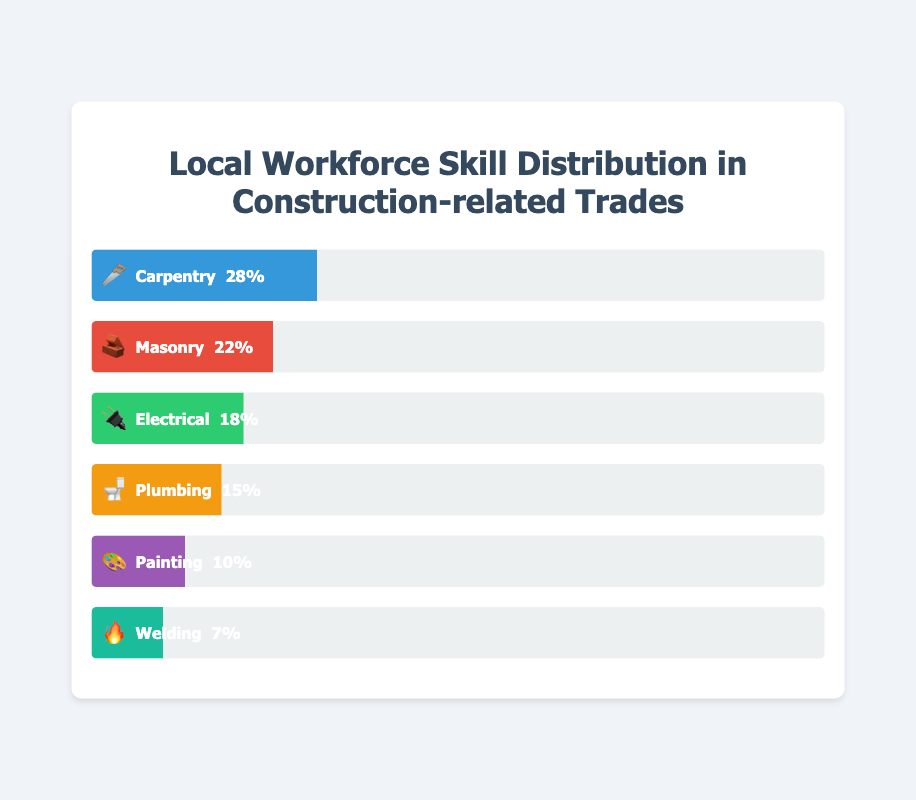What trade has the largest percentage of local workforce skills? The figure shows a bar representing each trade. The trade with the largest visible bar is "Carpentry 🪚." Its percentage is also noted on the bar.
Answer: Carpentry 🪚 What is the smallest percentage skill in construction-related trades? The figure lists percentages for each trade. The smallest number among them is "7%," attributed to "Welding 🔥."
Answer: Welding 🔥 What's the combined percentage of Electrical 🔌 and Plumbing 🚽 skills? Sum the percentages of Electrical (18%) and Plumbing (15%). The combined percentage is 18 + 15 = 33%.
Answer: 33% Which trade has a higher percentage, Painting 🎨 or Welding 🔥? Compare the percentages of Painting (10%) and Welding (7%). Painting's percentage is higher.
Answer: Painting 🎨 How much larger is the Carpentry 🪚 percentage compared to the Masonry 🧱 percentage? Subtract the percentage of Masonry (22%) from Carpentry (28%). The result is 28 - 22 = 6%.
Answer: 6% What's the total percentage of the local workforce skills represented in the figure? Add all the percentages: 28% (Carpentry) + 22% (Masonry) + 18% (Electrical) + 15% (Plumbing) + 10% (Painting) + 7% (Welding). The total is 28 + 22 + 18 + 15 + 10 + 7 = 100%.
Answer: 100% Which trade has the third highest percentage of local workforce skills? List the trades by percentage in descending order: 28% (Carpentry), 22% (Masonry), 18% (Electrical), 15% (Plumbing), 10% (Painting), and 7% (Welding). The third highest is Electrical at 18%.
Answer: Electrical 🔌 What is the difference in percentage points between the trade with the highest skill and the trade with the lowest skill? Subtract the percentage of the lowest skill (Welding, 7%) from the highest skill (Carpentry, 28%). The difference is 28 - 7 = 21%.
Answer: 21% If the skill distribution reflects the project needs, which two trades should receive more workforce training based on their current lower percentages? The two trades with the smallest percentages are Welding (7%) and Painting (10%). These should receive more training.
Answer: Welding 🔥 and Painting 🎨 